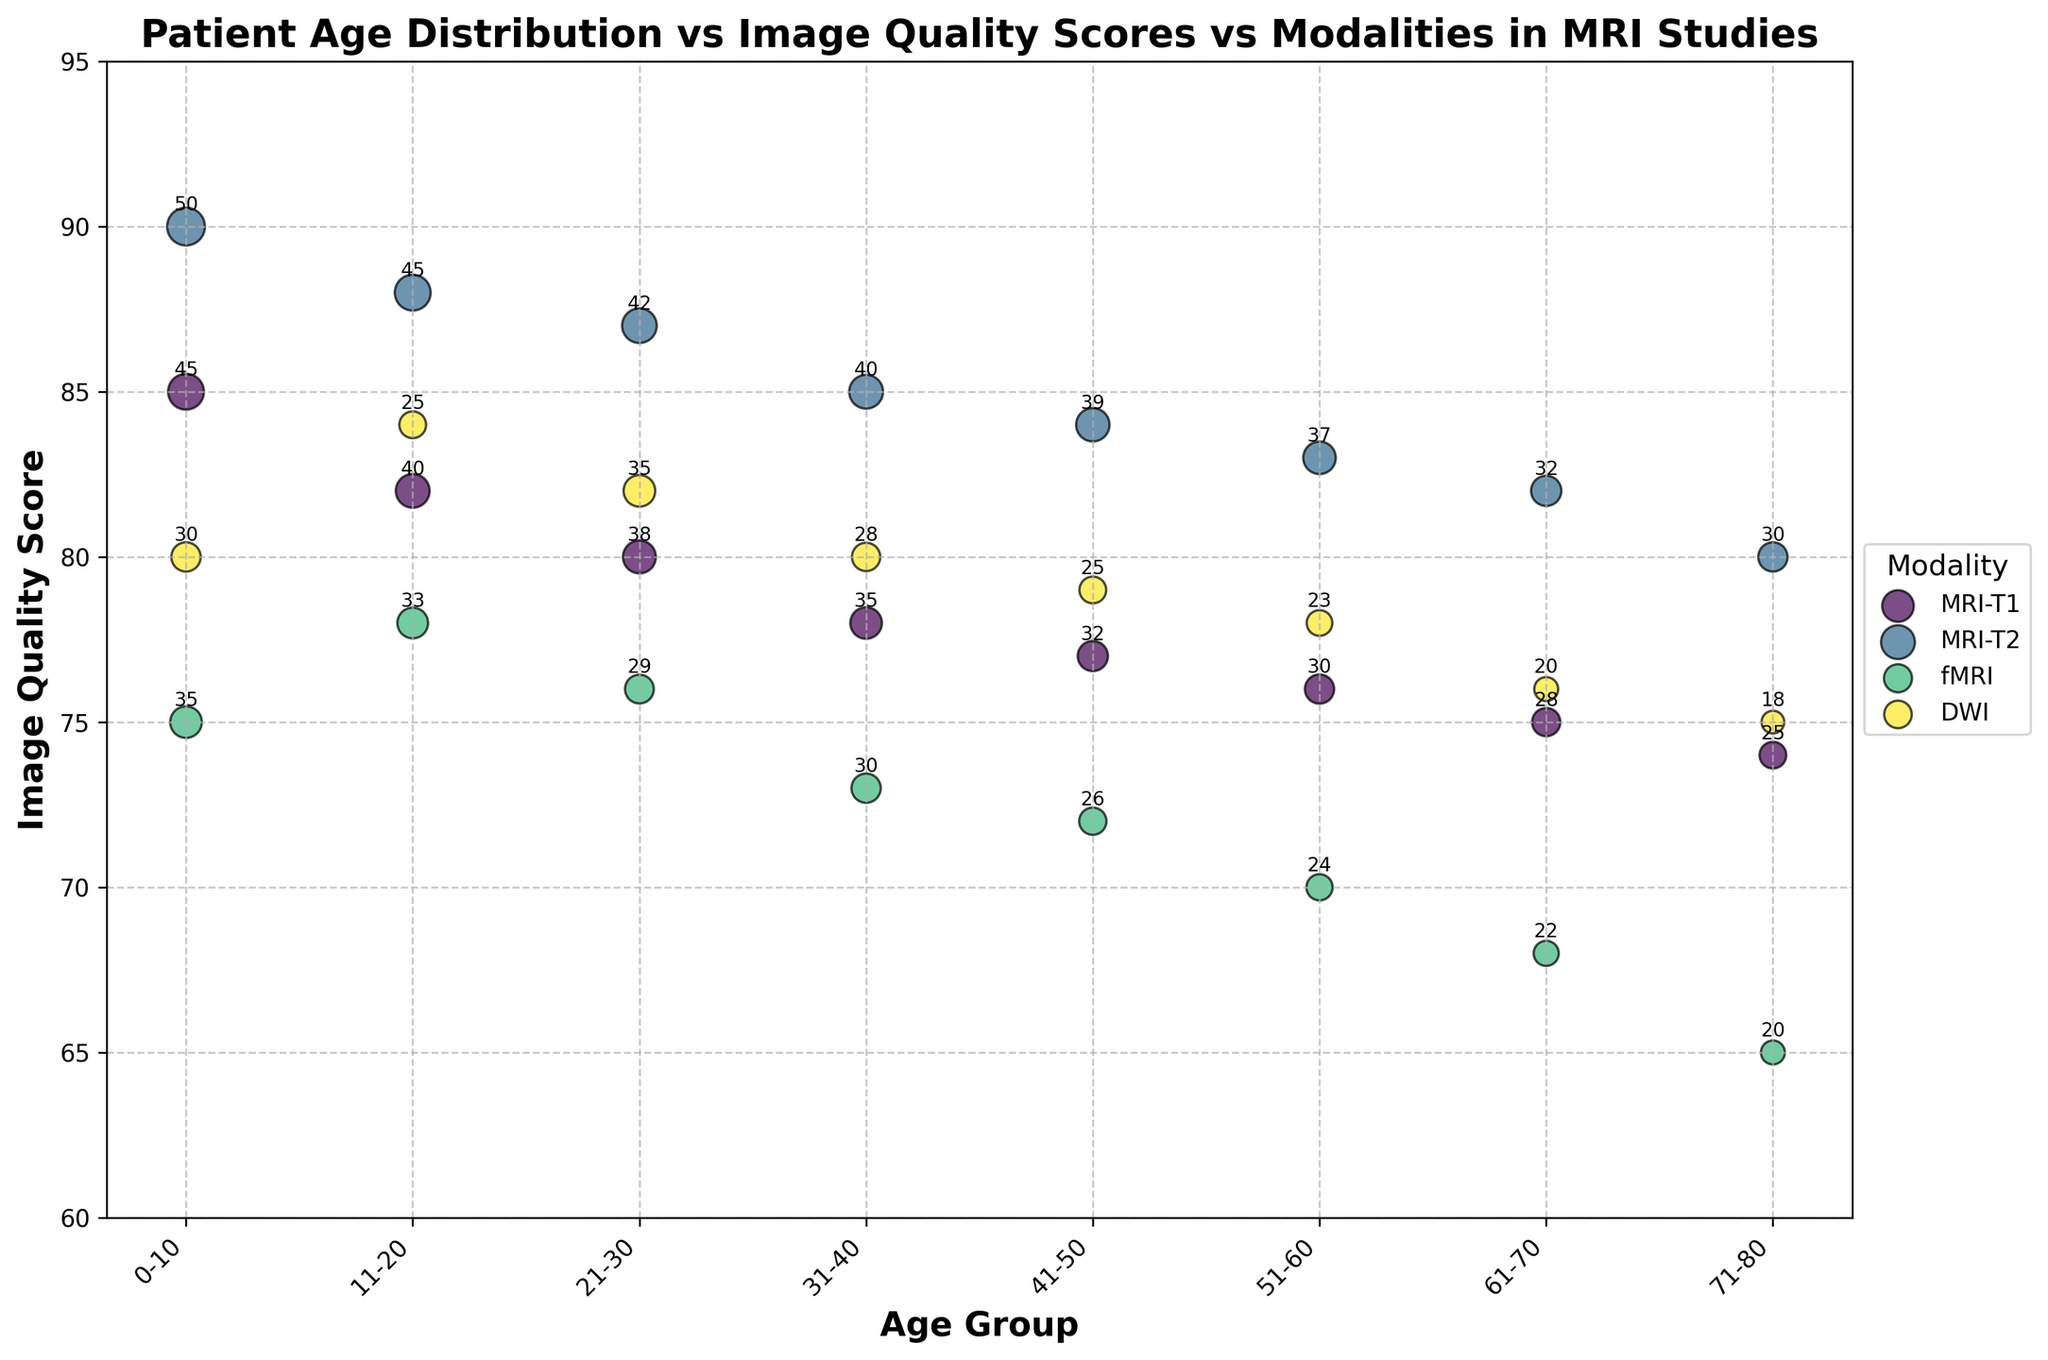What is the title of the figure? The title of the figure is shown at the top and reads "Patient Age Distribution vs Image Quality Scores vs Modalities in MRI Studies".
Answer: Patient Age Distribution vs Image Quality Scores vs Modalities in MRI Studies How many age groups are represented on the x-axis? The x-axis has ticks labeled with the different age groups, and by counting them, we can see there are 8 groups: 0-10, 11-20, 21-30, 31-40, 41-50, 51-60, 61-70, 71-80.
Answer: 8 Which MRI modality has the highest image quality score in the 0-10 age group? We look at the bubbles above the 0-10 age group's tick on the x-axis and find the maximum y-value. The MRI-T2 modality has the highest image quality score of 90.
Answer: MRI-T2 Which MRI modality has consistently decreasing image quality scores with increasing age groups? We observe the trend for each modality's image quality score across the age groups. The fMRI modality shows a consistent decrease from the 0-10 age group to the 71-80 age group.
Answer: fMRI What is the total number of patients in the 21-30 age group across all modalities? In the 21-30 age group, the number of patients is represented by the bubble sizes. We sum these values: MRI-T1 (38) + MRI-T2 (42) + fMRI (29) + DWI (35) = 144.
Answer: 144 Which age group has the largest number of patients for the MRI-T2 modality? We compare the bubble sizes (which represent the number of patients) for MRI-T2 across all age groups. The largest bubble size for MRI-T2 is in the 0-10 age group with 50 patients.
Answer: 0-10 Are there any age groups where all modalities have an image quality score above 80? We check each modality's score for each age group and find the age group where all scores exceed 80. In the 0-10 age group, all modalities (MRI-T1, MRI-T2, fMRI, DWI) have scores above 80.
Answer: 0-10 What is the difference in image quality scores between MRI-T1 and fMRI in the 61-70 age group? Subtract the image quality score of fMRI from MRI-T1 in the 61-70 age group: 75 (MRI-T1) - 68 (fMRI) = 7.
Answer: 7 